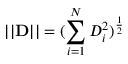<formula> <loc_0><loc_0><loc_500><loc_500>| | D | | = ( \sum _ { i = 1 } ^ { N } D _ { i } ^ { 2 } ) ^ { \frac { 1 } { 2 } }</formula> 